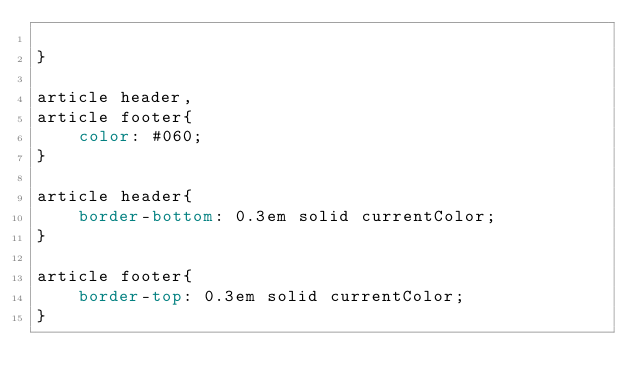Convert code to text. <code><loc_0><loc_0><loc_500><loc_500><_CSS_>
}

article header,
article footer{
    color: #060;
}

article header{
    border-bottom: 0.3em solid currentColor;
}

article footer{
    border-top: 0.3em solid currentColor;
}</code> 